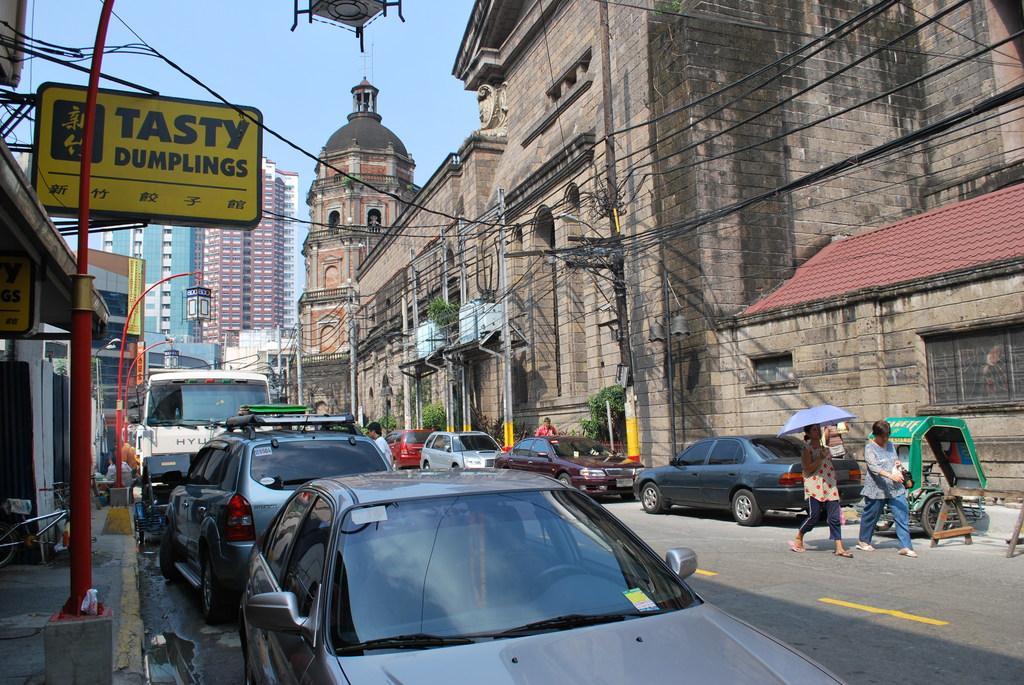In one or two sentences, can you explain what this image depicts? There is a road. On the road there are many vehicles. Also there are two persons walking on the road. One person is holding an umbrella. On the right side there is a building with brick wall. Also there are electric poles with wires. On the left side there is a name board. There are light poles. In the background there are many buildings and sky. 